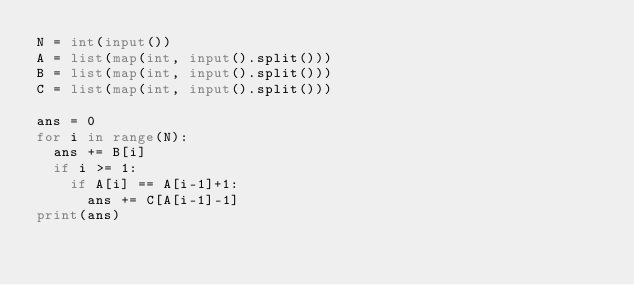<code> <loc_0><loc_0><loc_500><loc_500><_Python_>N = int(input())
A = list(map(int, input().split()))
B = list(map(int, input().split()))
C = list(map(int, input().split()))

ans = 0
for i in range(N):
	ans += B[i]
	if i >= 1:
		if A[i] == A[i-1]+1:
			ans += C[A[i-1]-1]
print(ans)</code> 